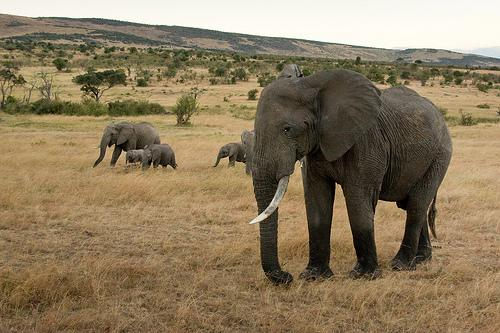Question: who took this photo?
Choices:
A. Friend.
B. Brother.
C. Mother.
D. Photographer.
Answer with the letter. Answer: D Question: when do elephants eat?
Choices:
A. In the morning.
B. When they have food.
C. When hungry.
D. During the evening.
Answer with the letter. Answer: C Question: how do the elephants appear to be standing?
Choices:
A. On all four legs.
B. Still.
C. Sitting on their haunches.
D. All in a row.
Answer with the letter. Answer: B Question: where are the elephants?
Choices:
A. Field.
B. River.
C. Desert.
D. Plains.
Answer with the letter. Answer: A Question: what is in the distant background?
Choices:
A. Mountains.
B. An ocean.
C. An open plain.
D. Sky.
Answer with the letter. Answer: D Question: what are the white objects on front of elephants faces?
Choices:
A. Teeth.
B. Horns.
C. Tusks.
D. Antlers.
Answer with the letter. Answer: C Question: what are these animals?
Choices:
A. Giraffes.
B. Zebras.
C. Elephants.
D. Hippos.
Answer with the letter. Answer: C 